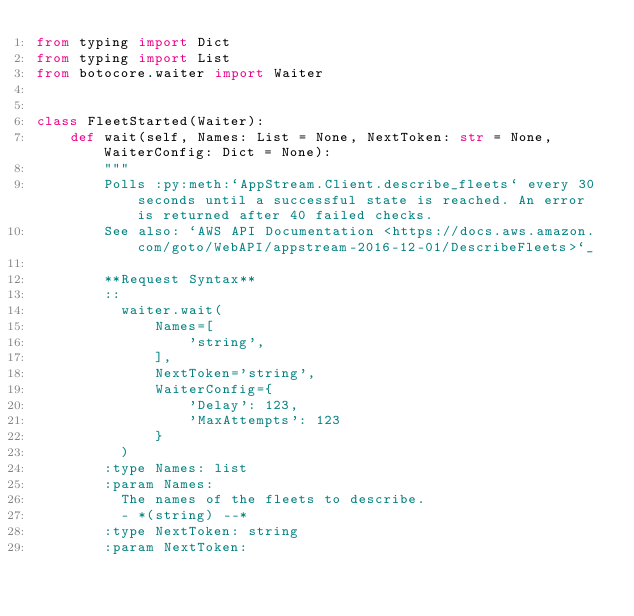Convert code to text. <code><loc_0><loc_0><loc_500><loc_500><_Python_>from typing import Dict
from typing import List
from botocore.waiter import Waiter


class FleetStarted(Waiter):
    def wait(self, Names: List = None, NextToken: str = None, WaiterConfig: Dict = None):
        """
        Polls :py:meth:`AppStream.Client.describe_fleets` every 30 seconds until a successful state is reached. An error is returned after 40 failed checks.
        See also: `AWS API Documentation <https://docs.aws.amazon.com/goto/WebAPI/appstream-2016-12-01/DescribeFleets>`_
        
        **Request Syntax**
        ::
          waiter.wait(
              Names=[
                  'string',
              ],
              NextToken='string',
              WaiterConfig={
                  'Delay': 123,
                  'MaxAttempts': 123
              }
          )
        :type Names: list
        :param Names:
          The names of the fleets to describe.
          - *(string) --*
        :type NextToken: string
        :param NextToken:</code> 